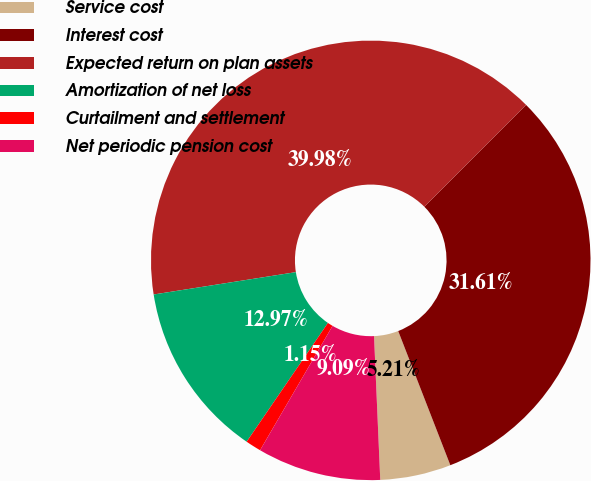Convert chart to OTSL. <chart><loc_0><loc_0><loc_500><loc_500><pie_chart><fcel>Service cost<fcel>Interest cost<fcel>Expected return on plan assets<fcel>Amortization of net loss<fcel>Curtailment and settlement<fcel>Net periodic pension cost<nl><fcel>5.21%<fcel>31.61%<fcel>39.98%<fcel>12.97%<fcel>1.15%<fcel>9.09%<nl></chart> 